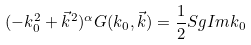<formula> <loc_0><loc_0><loc_500><loc_500>( - k _ { 0 } ^ { 2 } + \vec { k } ^ { 2 } ) ^ { \alpha } G ( k _ { 0 } , \vec { k } ) = \frac { 1 } { 2 } S g I m k _ { 0 }</formula> 